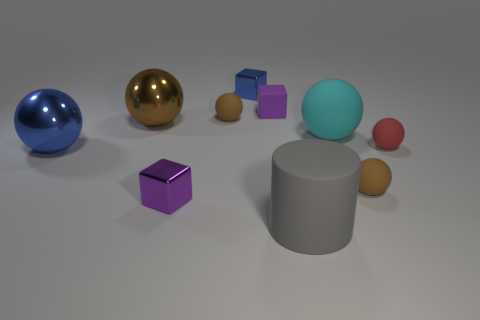Subtract all red cylinders. How many brown balls are left? 3 Subtract all small brown rubber spheres. How many spheres are left? 4 Subtract all red balls. How many balls are left? 5 Subtract 3 balls. How many balls are left? 3 Subtract all green spheres. Subtract all green cylinders. How many spheres are left? 6 Subtract all balls. How many objects are left? 4 Subtract all small purple matte objects. Subtract all tiny red objects. How many objects are left? 8 Add 9 cyan spheres. How many cyan spheres are left? 10 Add 4 matte cylinders. How many matte cylinders exist? 5 Subtract 0 cyan cubes. How many objects are left? 10 